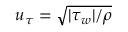Convert formula to latex. <formula><loc_0><loc_0><loc_500><loc_500>u _ { \tau } = \sqrt { | \tau _ { w } | / \rho }</formula> 